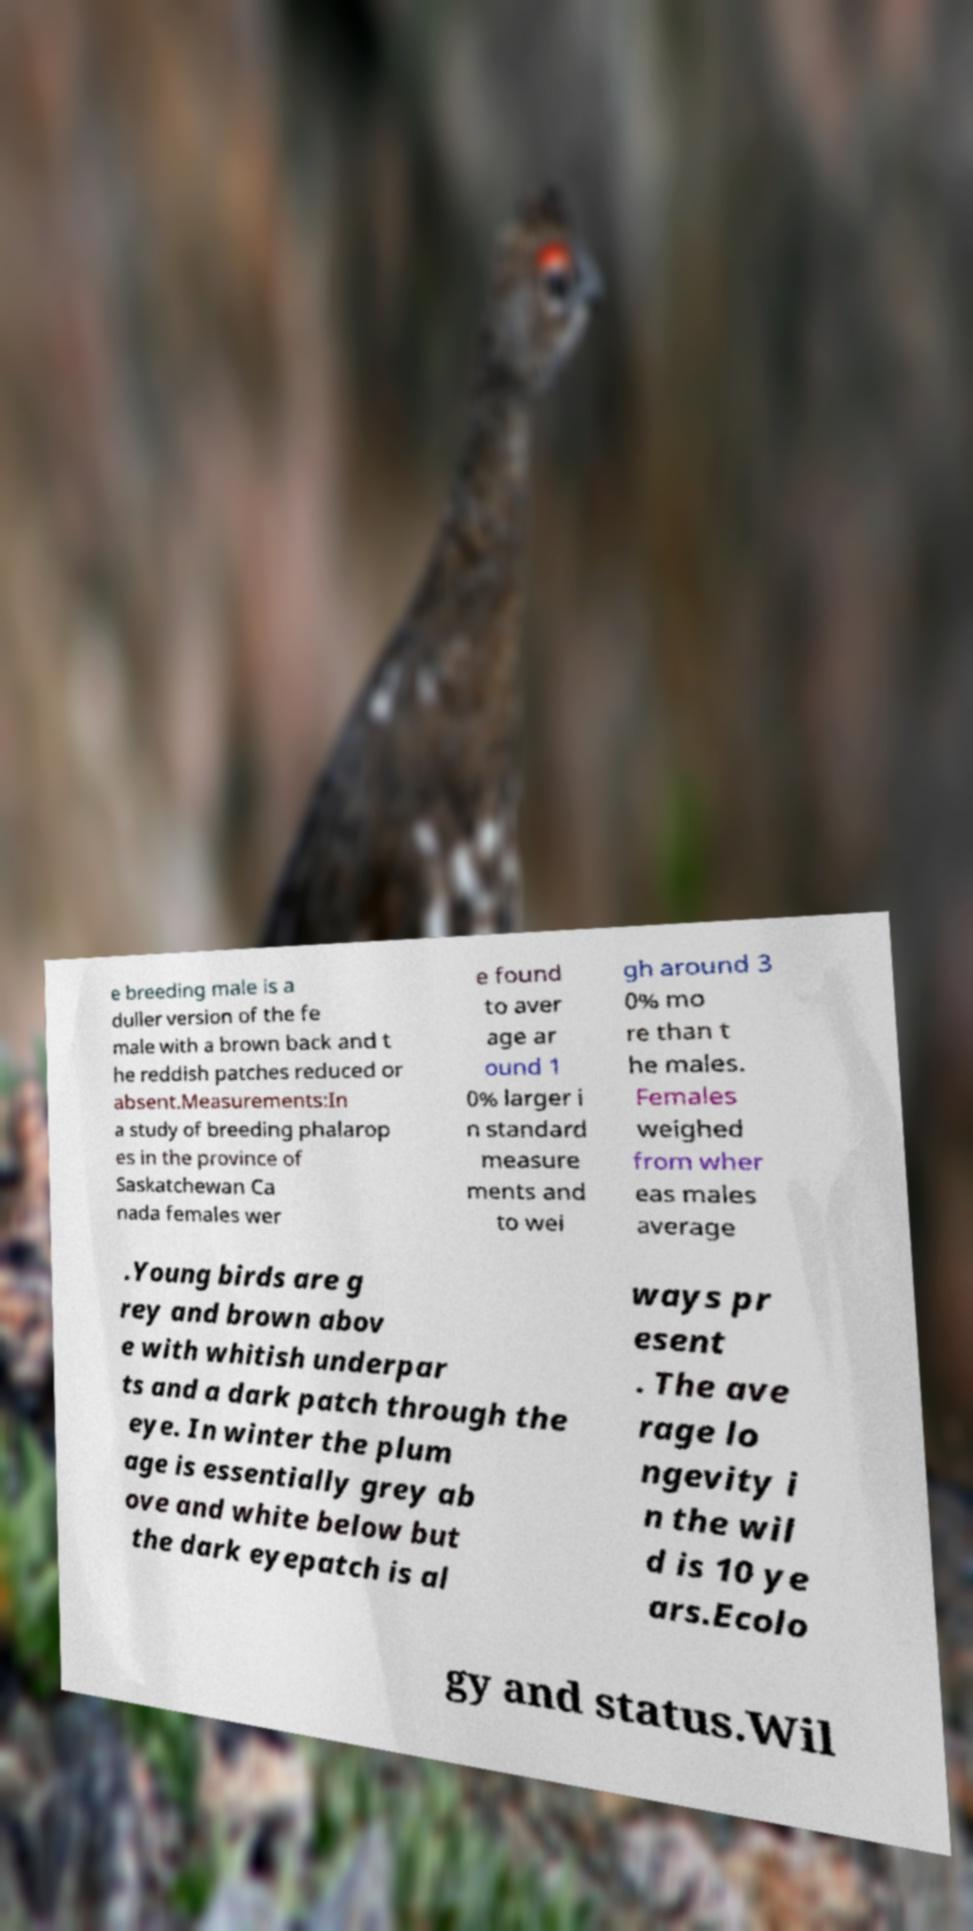Could you extract and type out the text from this image? e breeding male is a duller version of the fe male with a brown back and t he reddish patches reduced or absent.Measurements:In a study of breeding phalarop es in the province of Saskatchewan Ca nada females wer e found to aver age ar ound 1 0% larger i n standard measure ments and to wei gh around 3 0% mo re than t he males. Females weighed from wher eas males average .Young birds are g rey and brown abov e with whitish underpar ts and a dark patch through the eye. In winter the plum age is essentially grey ab ove and white below but the dark eyepatch is al ways pr esent . The ave rage lo ngevity i n the wil d is 10 ye ars.Ecolo gy and status.Wil 